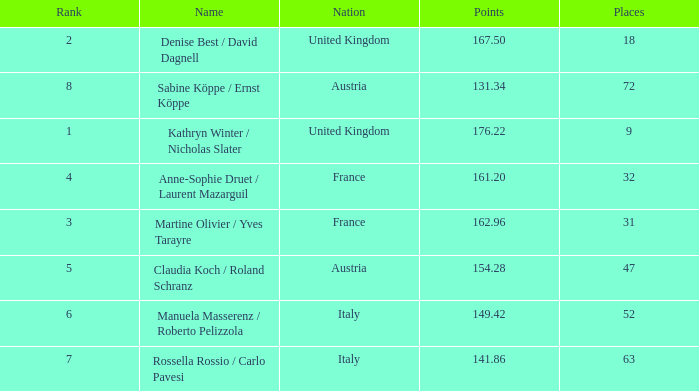Who has points larger than 167.5? Kathryn Winter / Nicholas Slater. 